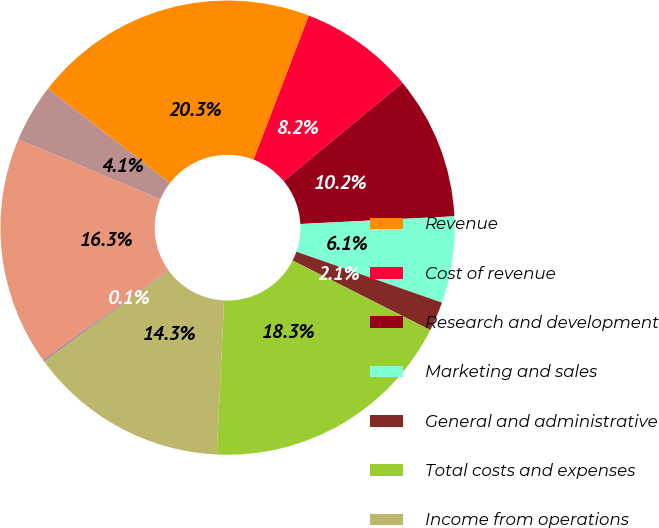Convert chart. <chart><loc_0><loc_0><loc_500><loc_500><pie_chart><fcel>Revenue<fcel>Cost of revenue<fcel>Research and development<fcel>Marketing and sales<fcel>General and administrative<fcel>Total costs and expenses<fcel>Income from operations<fcel>Interest and other<fcel>Income before provision for<fcel>Provision for income taxes<nl><fcel>20.34%<fcel>8.18%<fcel>10.2%<fcel>6.15%<fcel>2.09%<fcel>18.31%<fcel>14.26%<fcel>0.07%<fcel>16.28%<fcel>4.12%<nl></chart> 